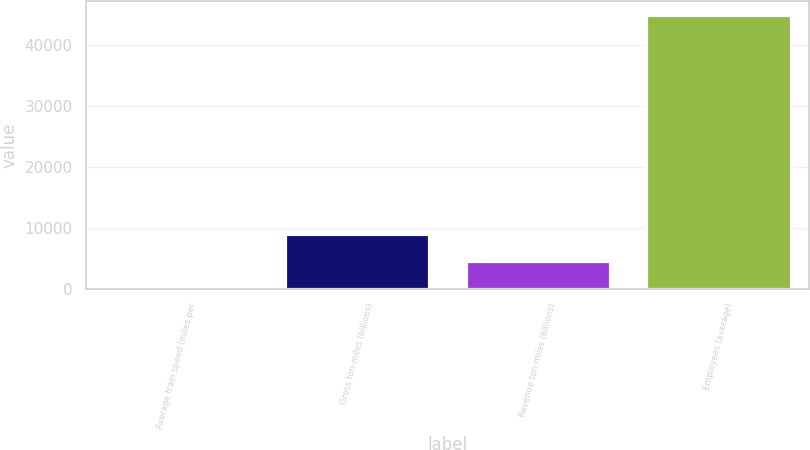Convert chart to OTSL. <chart><loc_0><loc_0><loc_500><loc_500><bar_chart><fcel>Average train speed (miles per<fcel>Gross ton-miles (billions)<fcel>Revenue ton-miles (billions)<fcel>Employees (average)<nl><fcel>25.6<fcel>8992.68<fcel>4509.14<fcel>44861<nl></chart> 